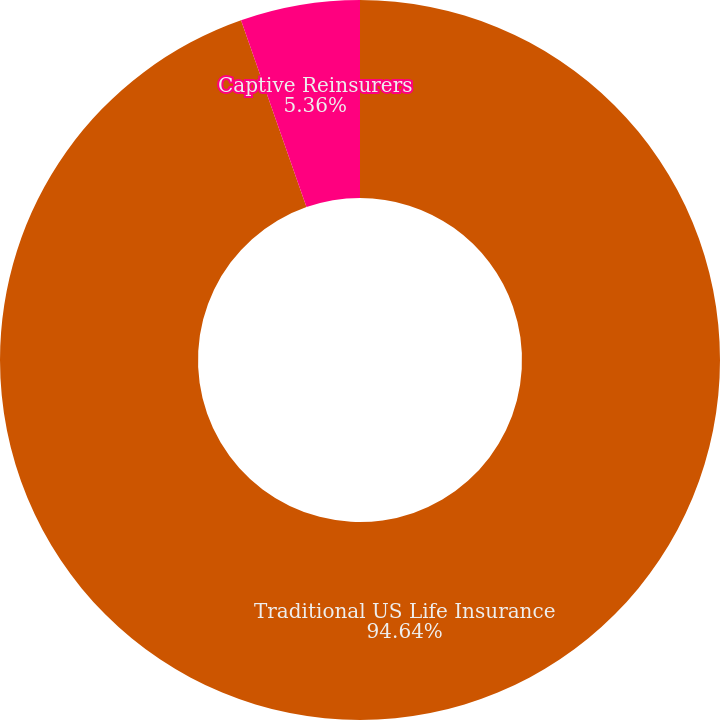Convert chart to OTSL. <chart><loc_0><loc_0><loc_500><loc_500><pie_chart><fcel>Traditional US Life Insurance<fcel>Captive Reinsurers<nl><fcel>94.64%<fcel>5.36%<nl></chart> 